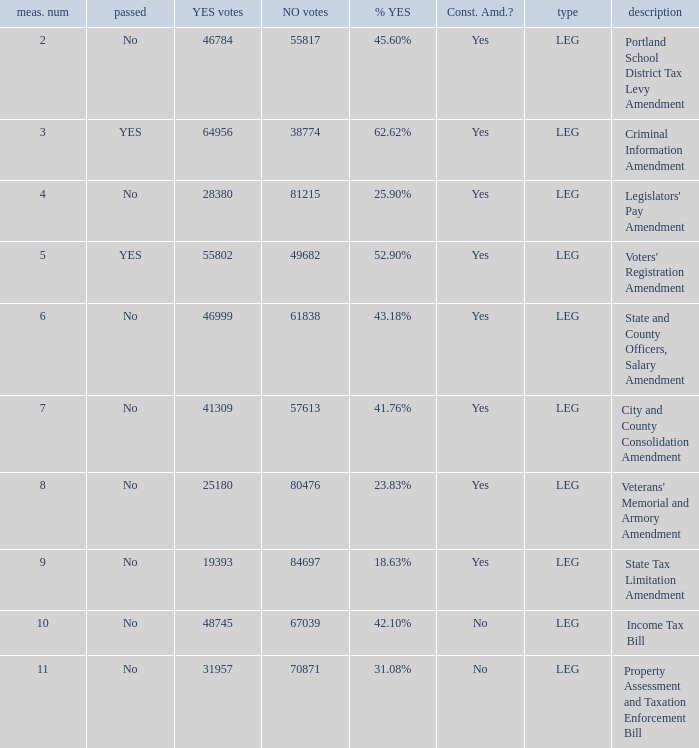If there were 45.60% yes votes, how many votes were against? 55817.0. 